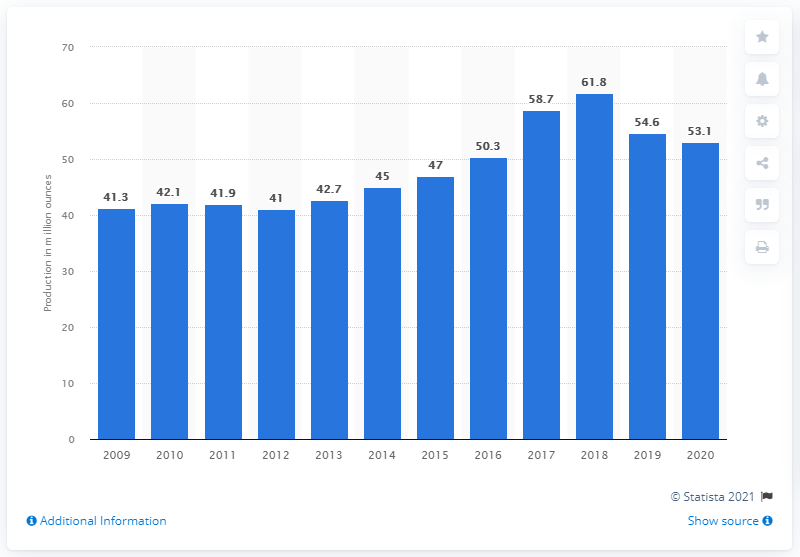Specify some key components in this picture. Fresnillo plc's annual silver production in 2020 was 53.1 million ounces. 